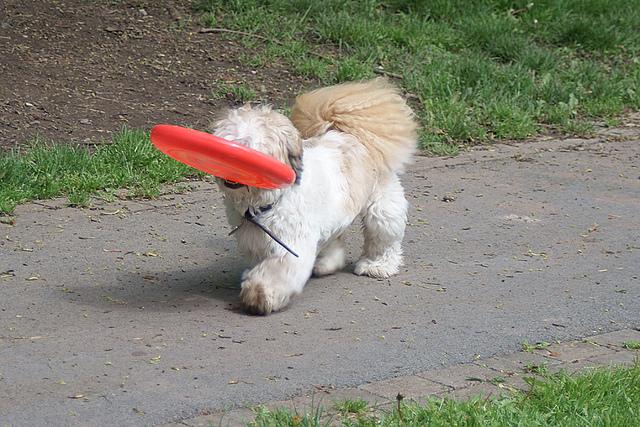Is the frisbee bigger than the dog?
Keep it brief. No. What is the dog carrying?
Short answer required. Frisbee. What breed of dog is shown?
Concise answer only. Shih tzu. 